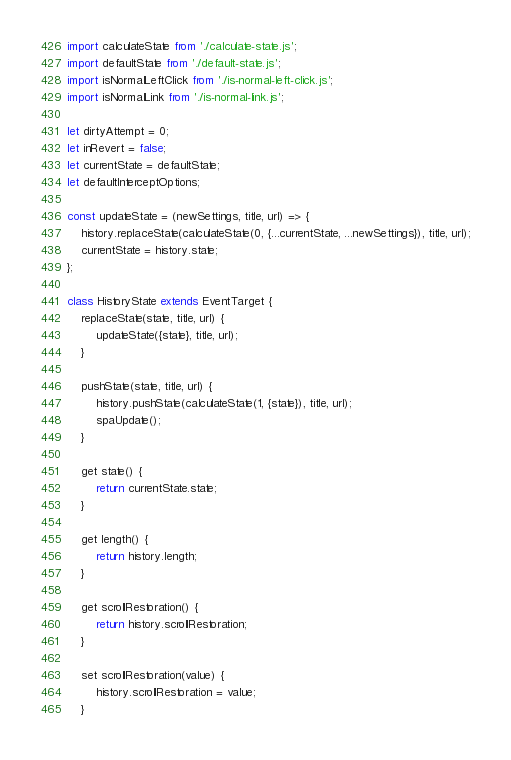<code> <loc_0><loc_0><loc_500><loc_500><_JavaScript_>import calculateState from './calculate-state.js';
import defaultState from './default-state.js';
import isNormalLeftClick from './is-normal-left-click.js';
import isNormalLink from './is-normal-link.js';

let dirtyAttempt = 0;
let inRevert = false;
let currentState = defaultState;
let defaultInterceptOptions;

const updateState = (newSettings, title, url) => {
	history.replaceState(calculateState(0, {...currentState, ...newSettings}), title, url);
	currentState = history.state;
};

class HistoryState extends EventTarget {
	replaceState(state, title, url) {
		updateState({state}, title, url);
	}

	pushState(state, title, url) {
		history.pushState(calculateState(1, {state}), title, url);
		spaUpdate();
	}

	get state() {
		return currentState.state;
	}

	get length() {
		return history.length;
	}

	get scrollRestoration() {
		return history.scrollRestoration;
	}

	set scrollRestoration(value) {
		history.scrollRestoration = value;
	}
</code> 